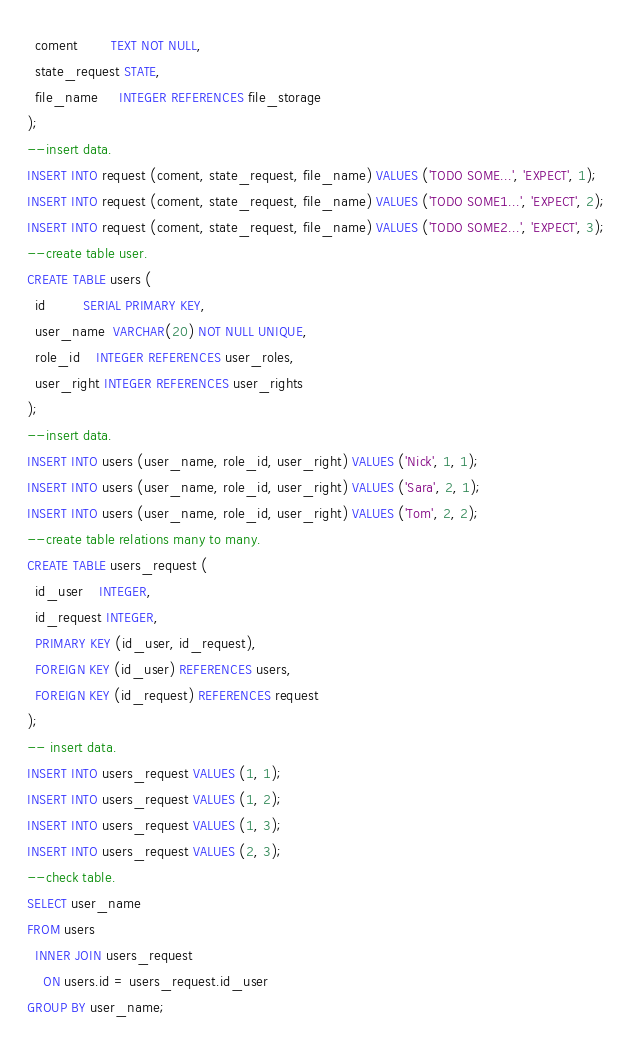Convert code to text. <code><loc_0><loc_0><loc_500><loc_500><_SQL_>  coment        TEXT NOT NULL,
  state_request STATE,
  file_name     INTEGER REFERENCES file_storage
);
--insert data.
INSERT INTO request (coment, state_request, file_name) VALUES ('TODO SOME...', 'EXPECT', 1);
INSERT INTO request (coment, state_request, file_name) VALUES ('TODO SOME1...', 'EXPECT', 2);
INSERT INTO request (coment, state_request, file_name) VALUES ('TODO SOME2...', 'EXPECT', 3);
--create table user.
CREATE TABLE users (
  id         SERIAL PRIMARY KEY,
  user_name  VARCHAR(20) NOT NULL UNIQUE,
  role_id    INTEGER REFERENCES user_roles,
  user_right INTEGER REFERENCES user_rights
);
--insert data.
INSERT INTO users (user_name, role_id, user_right) VALUES ('Nick', 1, 1);
INSERT INTO users (user_name, role_id, user_right) VALUES ('Sara', 2, 1);
INSERT INTO users (user_name, role_id, user_right) VALUES ('Tom', 2, 2);
--create table relations many to many.
CREATE TABLE users_request (
  id_user    INTEGER,
  id_request INTEGER,
  PRIMARY KEY (id_user, id_request),
  FOREIGN KEY (id_user) REFERENCES users,
  FOREIGN KEY (id_request) REFERENCES request
);
-- insert data.
INSERT INTO users_request VALUES (1, 1);
INSERT INTO users_request VALUES (1, 2);
INSERT INTO users_request VALUES (1, 3);
INSERT INTO users_request VALUES (2, 3);
--check table.
SELECT user_name
FROM users
  INNER JOIN users_request
    ON users.id = users_request.id_user
GROUP BY user_name;




</code> 